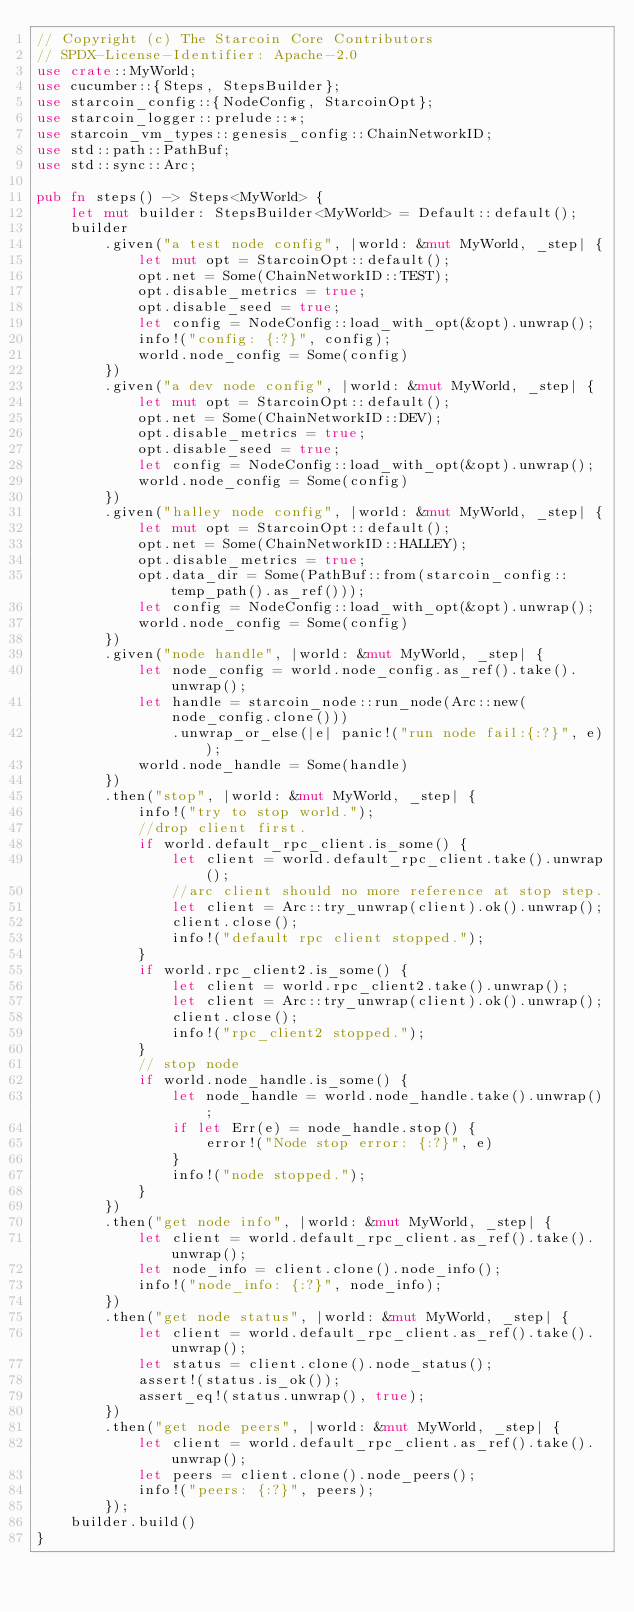Convert code to text. <code><loc_0><loc_0><loc_500><loc_500><_Rust_>// Copyright (c) The Starcoin Core Contributors
// SPDX-License-Identifier: Apache-2.0
use crate::MyWorld;
use cucumber::{Steps, StepsBuilder};
use starcoin_config::{NodeConfig, StarcoinOpt};
use starcoin_logger::prelude::*;
use starcoin_vm_types::genesis_config::ChainNetworkID;
use std::path::PathBuf;
use std::sync::Arc;

pub fn steps() -> Steps<MyWorld> {
    let mut builder: StepsBuilder<MyWorld> = Default::default();
    builder
        .given("a test node config", |world: &mut MyWorld, _step| {
            let mut opt = StarcoinOpt::default();
            opt.net = Some(ChainNetworkID::TEST);
            opt.disable_metrics = true;
            opt.disable_seed = true;
            let config = NodeConfig::load_with_opt(&opt).unwrap();
            info!("config: {:?}", config);
            world.node_config = Some(config)
        })
        .given("a dev node config", |world: &mut MyWorld, _step| {
            let mut opt = StarcoinOpt::default();
            opt.net = Some(ChainNetworkID::DEV);
            opt.disable_metrics = true;
            opt.disable_seed = true;
            let config = NodeConfig::load_with_opt(&opt).unwrap();
            world.node_config = Some(config)
        })
        .given("halley node config", |world: &mut MyWorld, _step| {
            let mut opt = StarcoinOpt::default();
            opt.net = Some(ChainNetworkID::HALLEY);
            opt.disable_metrics = true;
            opt.data_dir = Some(PathBuf::from(starcoin_config::temp_path().as_ref()));
            let config = NodeConfig::load_with_opt(&opt).unwrap();
            world.node_config = Some(config)
        })
        .given("node handle", |world: &mut MyWorld, _step| {
            let node_config = world.node_config.as_ref().take().unwrap();
            let handle = starcoin_node::run_node(Arc::new(node_config.clone()))
                .unwrap_or_else(|e| panic!("run node fail:{:?}", e));
            world.node_handle = Some(handle)
        })
        .then("stop", |world: &mut MyWorld, _step| {
            info!("try to stop world.");
            //drop client first.
            if world.default_rpc_client.is_some() {
                let client = world.default_rpc_client.take().unwrap();
                //arc client should no more reference at stop step.
                let client = Arc::try_unwrap(client).ok().unwrap();
                client.close();
                info!("default rpc client stopped.");
            }
            if world.rpc_client2.is_some() {
                let client = world.rpc_client2.take().unwrap();
                let client = Arc::try_unwrap(client).ok().unwrap();
                client.close();
                info!("rpc_client2 stopped.");
            }
            // stop node
            if world.node_handle.is_some() {
                let node_handle = world.node_handle.take().unwrap();
                if let Err(e) = node_handle.stop() {
                    error!("Node stop error: {:?}", e)
                }
                info!("node stopped.");
            }
        })
        .then("get node info", |world: &mut MyWorld, _step| {
            let client = world.default_rpc_client.as_ref().take().unwrap();
            let node_info = client.clone().node_info();
            info!("node_info: {:?}", node_info);
        })
        .then("get node status", |world: &mut MyWorld, _step| {
            let client = world.default_rpc_client.as_ref().take().unwrap();
            let status = client.clone().node_status();
            assert!(status.is_ok());
            assert_eq!(status.unwrap(), true);
        })
        .then("get node peers", |world: &mut MyWorld, _step| {
            let client = world.default_rpc_client.as_ref().take().unwrap();
            let peers = client.clone().node_peers();
            info!("peers: {:?}", peers);
        });
    builder.build()
}
</code> 